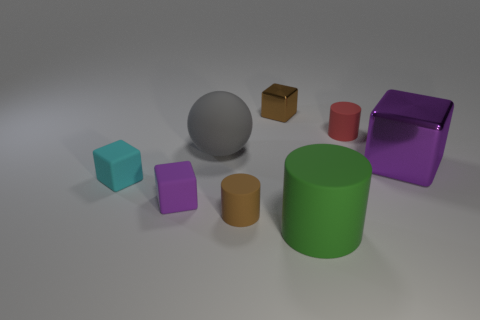Are the block that is behind the gray sphere and the small cyan cube made of the same material?
Give a very brief answer. No. How many other things are made of the same material as the tiny cyan thing?
Keep it short and to the point. 5. What number of things are things that are behind the gray matte sphere or tiny matte things in front of the cyan rubber cube?
Your response must be concise. 4. Is the shape of the big matte thing that is to the left of the green rubber cylinder the same as the tiny cyan thing behind the green object?
Your answer should be very brief. No. The purple object that is the same size as the green object is what shape?
Ensure brevity in your answer.  Cube. How many metallic objects are either small cyan cubes or tiny blocks?
Provide a short and direct response. 1. Is the material of the purple cube that is in front of the purple shiny thing the same as the tiny brown thing that is behind the big gray object?
Offer a terse response. No. There is a big sphere that is the same material as the cyan thing; what color is it?
Provide a short and direct response. Gray. Is the number of small matte cylinders that are to the left of the big green cylinder greater than the number of big gray spheres that are left of the gray thing?
Provide a short and direct response. Yes. Are there any big red rubber cubes?
Offer a very short reply. No. 